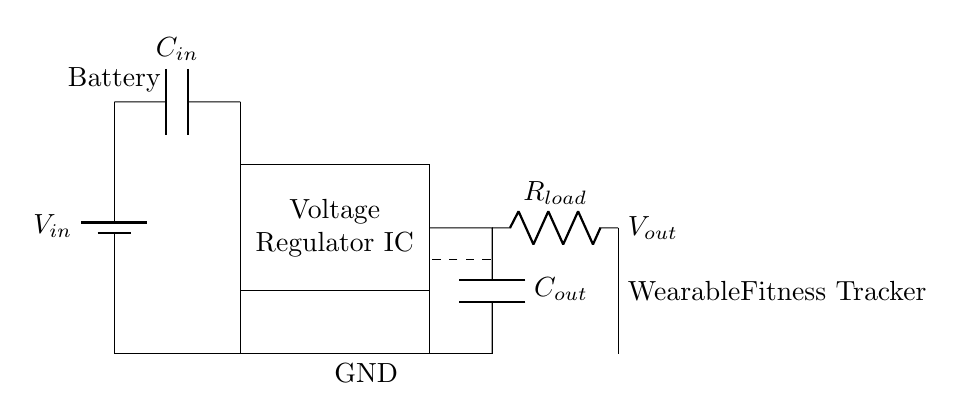What is the input voltage of the circuit? The input voltage is denoted as V_{in}, which is connected to the battery at the top of the circuit diagram.
Answer: V_{in} What component regulates the output voltage? The output voltage is regulated by the Voltage Regulator IC, which is shown as a rectangle in the center of the diagram and is responsible for providing a stable output voltage.
Answer: Voltage Regulator IC What is the function of capacitor C_{in}? Capacitor C_{in} is used for input smoothing. It filters the input voltage from the battery to stabilize it before it arrives at the voltage regulator, which is crucial for the performance of the circuit.
Answer: Input smoothing What connects the output to the load? The output connects to the load through R_{load}, which is a resistor in series with the output capacitor and draws current for the wearable fitness tracker.
Answer: R_{load} What role does capacitor C_{out} play? Capacitor C_{out} acts as a decoupling capacitor, helping to maintain stable voltage at the output by filtering high-frequency noise and providing a reservoir of charge when needed.
Answer: Decoupling What happens when the load is increased? Increasing the load will require more current, potentially causing the output voltage to drop if it exceeds the capacity of the voltage regulator, as it may not be able to maintain a stable output under heavy load conditions.
Answer: Output voltage drop 